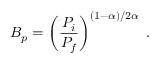<formula> <loc_0><loc_0><loc_500><loc_500>B _ { p } = \left ( \frac { P _ { i } } { P _ { f } } \right ) ^ { ( 1 - \alpha ) / 2 \alpha } \, .</formula> 